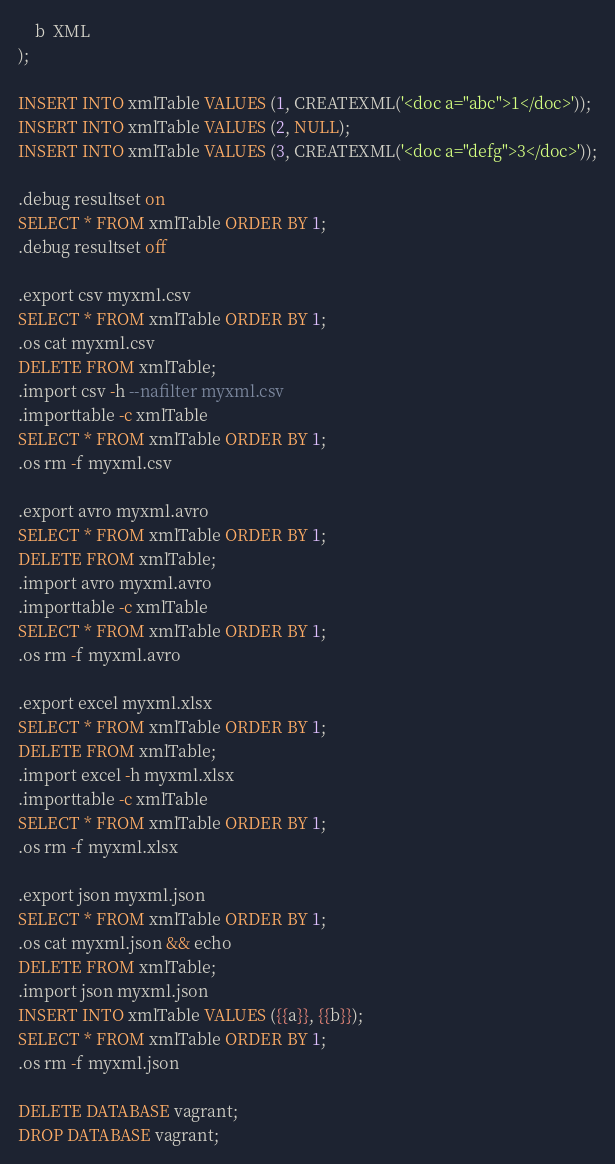<code> <loc_0><loc_0><loc_500><loc_500><_SQL_>	b  XML
);

INSERT INTO xmlTable VALUES (1, CREATEXML('<doc a="abc">1</doc>'));
INSERT INTO xmlTable VALUES (2, NULL);
INSERT INTO xmlTable VALUES (3, CREATEXML('<doc a="defg">3</doc>'));

.debug resultset on
SELECT * FROM xmlTable ORDER BY 1;
.debug resultset off

.export csv myxml.csv
SELECT * FROM xmlTable ORDER BY 1;
.os cat myxml.csv
DELETE FROM xmlTable;
.import csv -h --nafilter myxml.csv
.importtable -c xmlTable
SELECT * FROM xmlTable ORDER BY 1;
.os rm -f myxml.csv

.export avro myxml.avro
SELECT * FROM xmlTable ORDER BY 1;
DELETE FROM xmlTable;
.import avro myxml.avro
.importtable -c xmlTable
SELECT * FROM xmlTable ORDER BY 1;
.os rm -f myxml.avro

.export excel myxml.xlsx
SELECT * FROM xmlTable ORDER BY 1;
DELETE FROM xmlTable;
.import excel -h myxml.xlsx
.importtable -c xmlTable
SELECT * FROM xmlTable ORDER BY 1;
.os rm -f myxml.xlsx

.export json myxml.json
SELECT * FROM xmlTable ORDER BY 1;
.os cat myxml.json && echo
DELETE FROM xmlTable;
.import json myxml.json
INSERT INTO xmlTable VALUES ({{a}}, {{b}});
SELECT * FROM xmlTable ORDER BY 1;
.os rm -f myxml.json

DELETE DATABASE vagrant;
DROP DATABASE vagrant;
</code> 